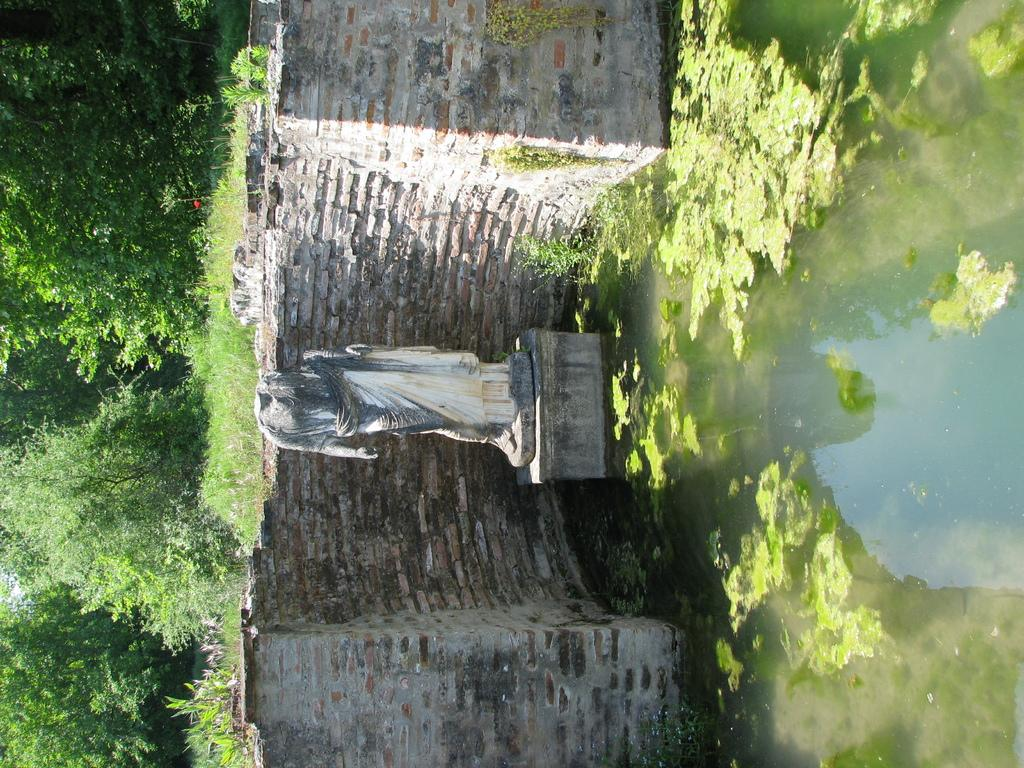What is the main subject of the image? There is a sculpture in the image. What type of background can be seen behind the sculpture? There is a brick wall in the image. What natural elements are present in the image? Water, grass, and trees are present in the image. Can you describe the water in the image? Water is visible in the image, and water algae are present in the water. How does the sculpture start to untie the knot in the image? There is no knot present in the image, and the sculpture is not shown performing any actions. 